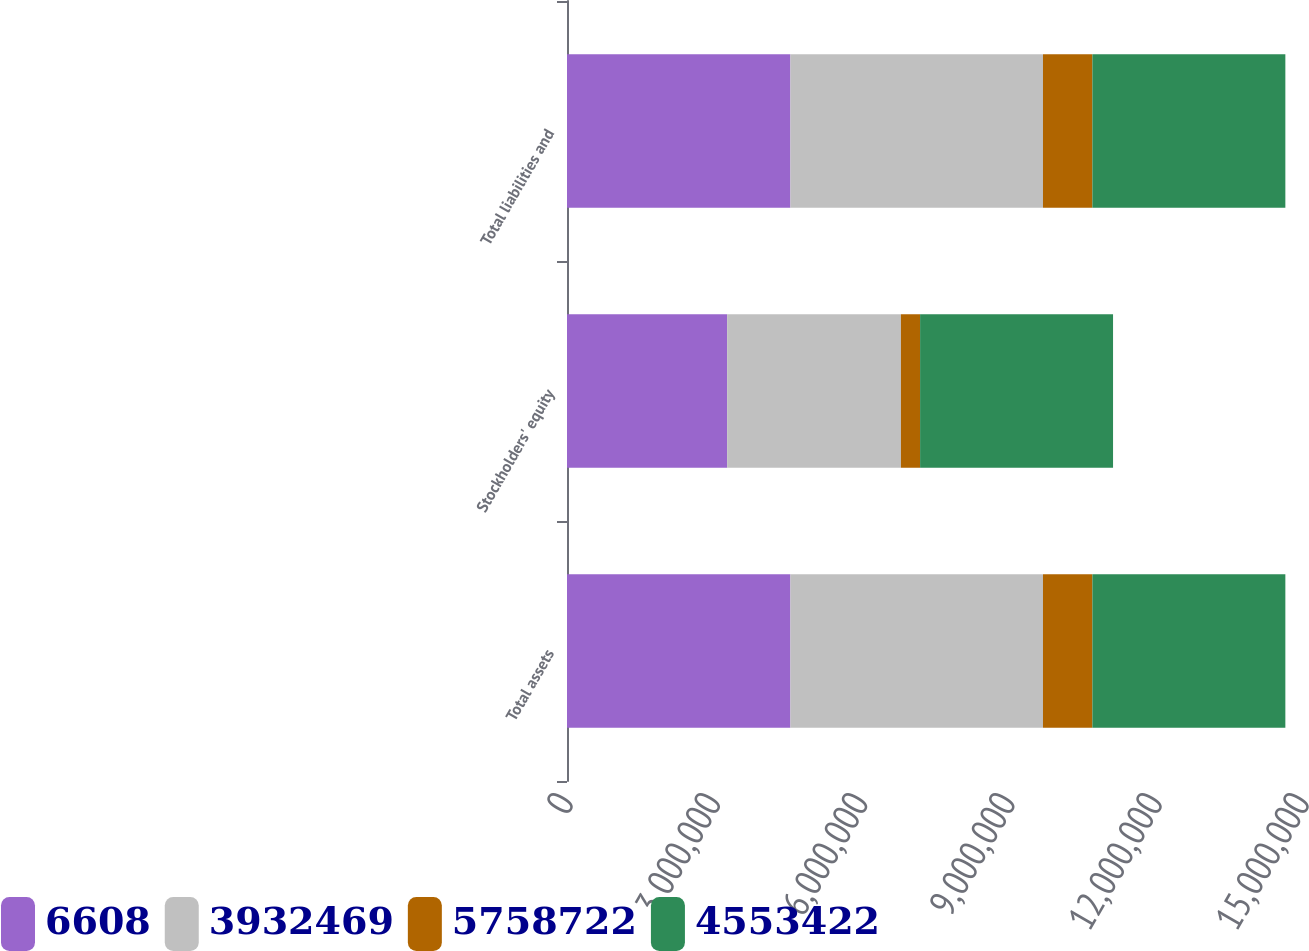Convert chart to OTSL. <chart><loc_0><loc_0><loc_500><loc_500><stacked_bar_chart><ecel><fcel>Total assets<fcel>Stockholders' equity<fcel>Total liabilities and<nl><fcel>6608<fcel>4.55342e+06<fcel>3.26377e+06<fcel>4.55342e+06<nl><fcel>3.93247e+06<fcel>5.14745e+06<fcel>3.54175e+06<fcel>5.14745e+06<nl><fcel>5.75872e+06<fcel>1.00703e+06<fcel>390722<fcel>1.00703e+06<nl><fcel>4.55342e+06<fcel>3.93247e+06<fcel>3.93247e+06<fcel>3.93247e+06<nl></chart> 